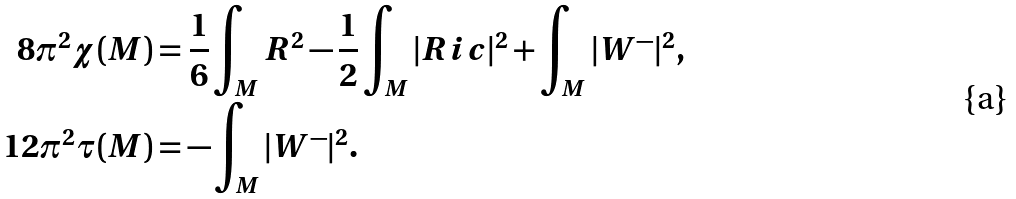Convert formula to latex. <formula><loc_0><loc_0><loc_500><loc_500>8 \pi ^ { 2 } \chi ( M ) & = \frac { 1 } { 6 } \int _ { M } R ^ { 2 } - \frac { 1 } { 2 } \int _ { M } | R i c | ^ { 2 } + \int _ { M } | W ^ { - } | ^ { 2 } , \\ 1 2 \pi ^ { 2 } \tau ( M ) & = - \int _ { M } | W ^ { - } | ^ { 2 } .</formula> 